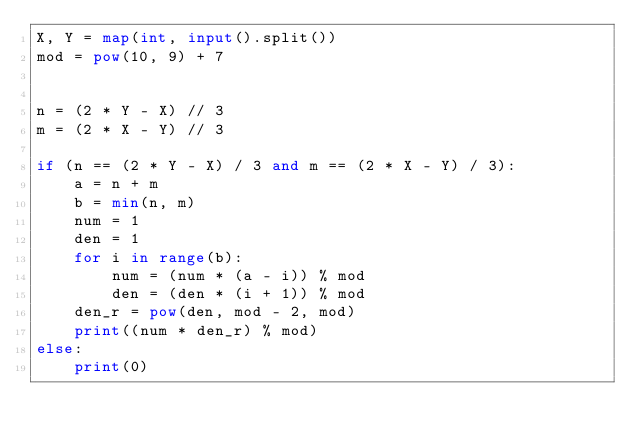Convert code to text. <code><loc_0><loc_0><loc_500><loc_500><_Python_>X, Y = map(int, input().split())
mod = pow(10, 9) + 7


n = (2 * Y - X) // 3
m = (2 * X - Y) // 3

if (n == (2 * Y - X) / 3 and m == (2 * X - Y) / 3):
    a = n + m
    b = min(n, m)
    num = 1
    den = 1
    for i in range(b):
        num = (num * (a - i)) % mod
        den = (den * (i + 1)) % mod
    den_r = pow(den, mod - 2, mod)
    print((num * den_r) % mod)
else:
    print(0)
</code> 